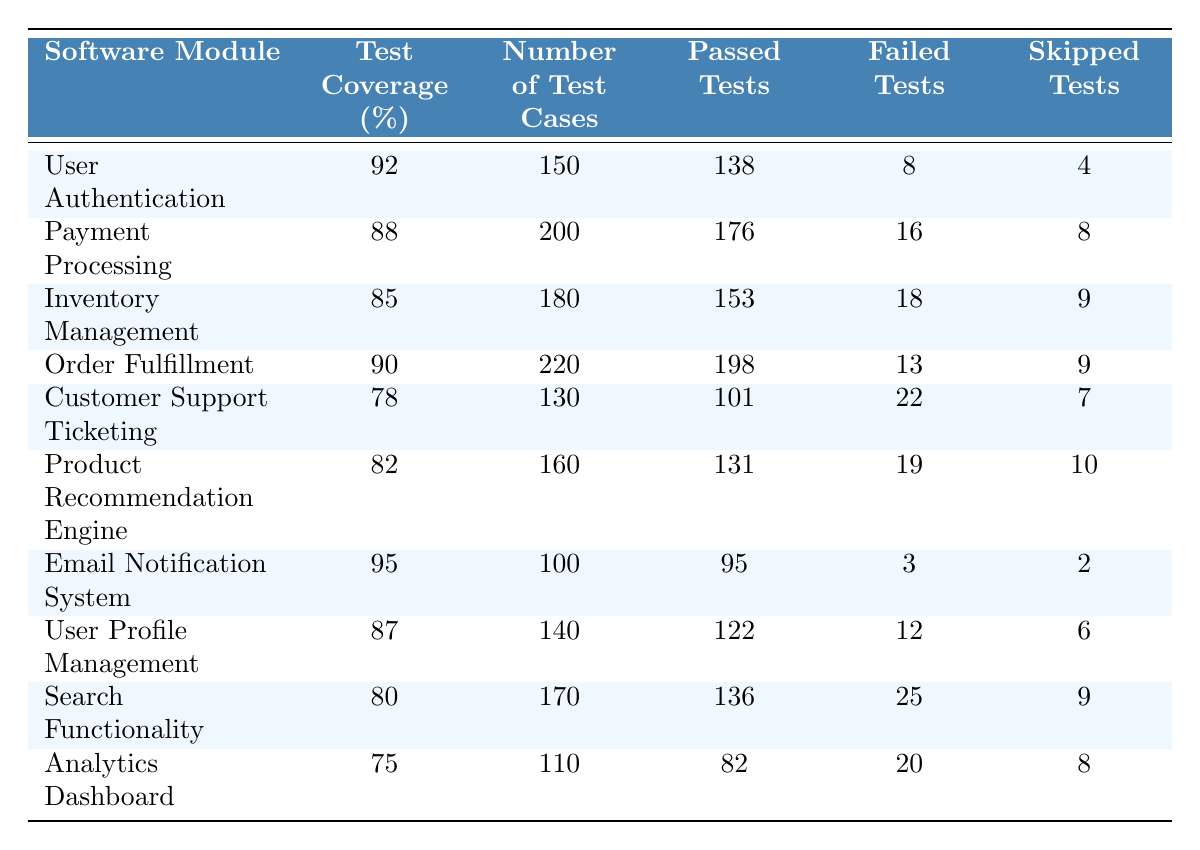What is the test coverage percentage for the User Authentication module? The table shows that the test coverage percentage for the User Authentication module is listed as 92%.
Answer: 92% How many test cases were used for the Payment Processing module? The table indicates that there were 200 test cases used for the Payment Processing module.
Answer: 200 Which module has the highest number of passed tests? By examining the table, the Order Fulfillment module has the highest number of passed tests, totaling 198.
Answer: 198 What is the sum of skipped tests for both the Inventory Management and Customer Support Ticketing modules? The skipped tests for Inventory Management is 9 and for Customer Support Ticketing is 7. Summing these gives 9 + 7 = 16.
Answer: 16 Is the test coverage percentage for the Analytics Dashboard greater than 80%? The test coverage for the Analytics Dashboard is 75%, which is not greater than 80%.
Answer: No Which module has the least test coverage? Looking at the test coverage percentages, the Customer Support Ticketing module has the least, with 78%.
Answer: 78% What is the average number of passed tests across all modules listed? The total number of passed tests is 138 + 176 + 153 + 198 + 101 + 131 + 95 + 122 + 136 + 82 = 1,201. With 10 modules, the average is 1,201 / 10 = 120.1.
Answer: 120.1 How many failed tests does the User Profile Management module have? The table shows that the User Profile Management module has 12 failed tests.
Answer: 12 Which module has a test coverage percentage that is exactly 85%? Inspecting the table shows that the Inventory Management module is listed with a test coverage of 85%.
Answer: Inventory Management What is the difference in the number of test cases between the Email Notification System and the Order Fulfillment module? The Email Notification System has 100 test cases, while the Order Fulfillment module has 220. The difference is 220 - 100 = 120.
Answer: 120 